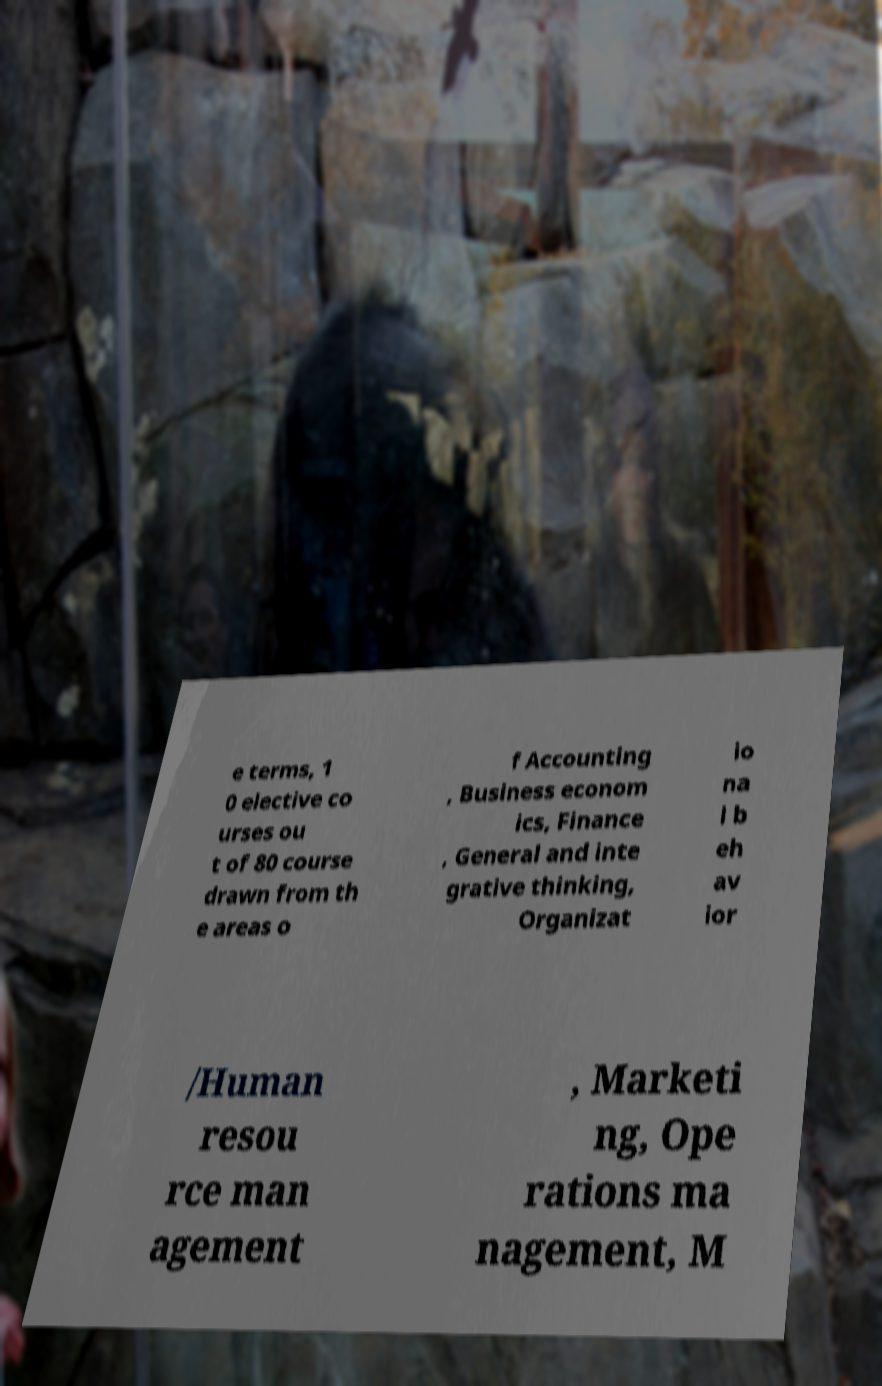Please read and relay the text visible in this image. What does it say? e terms, 1 0 elective co urses ou t of 80 course drawn from th e areas o f Accounting , Business econom ics, Finance , General and inte grative thinking, Organizat io na l b eh av ior /Human resou rce man agement , Marketi ng, Ope rations ma nagement, M 